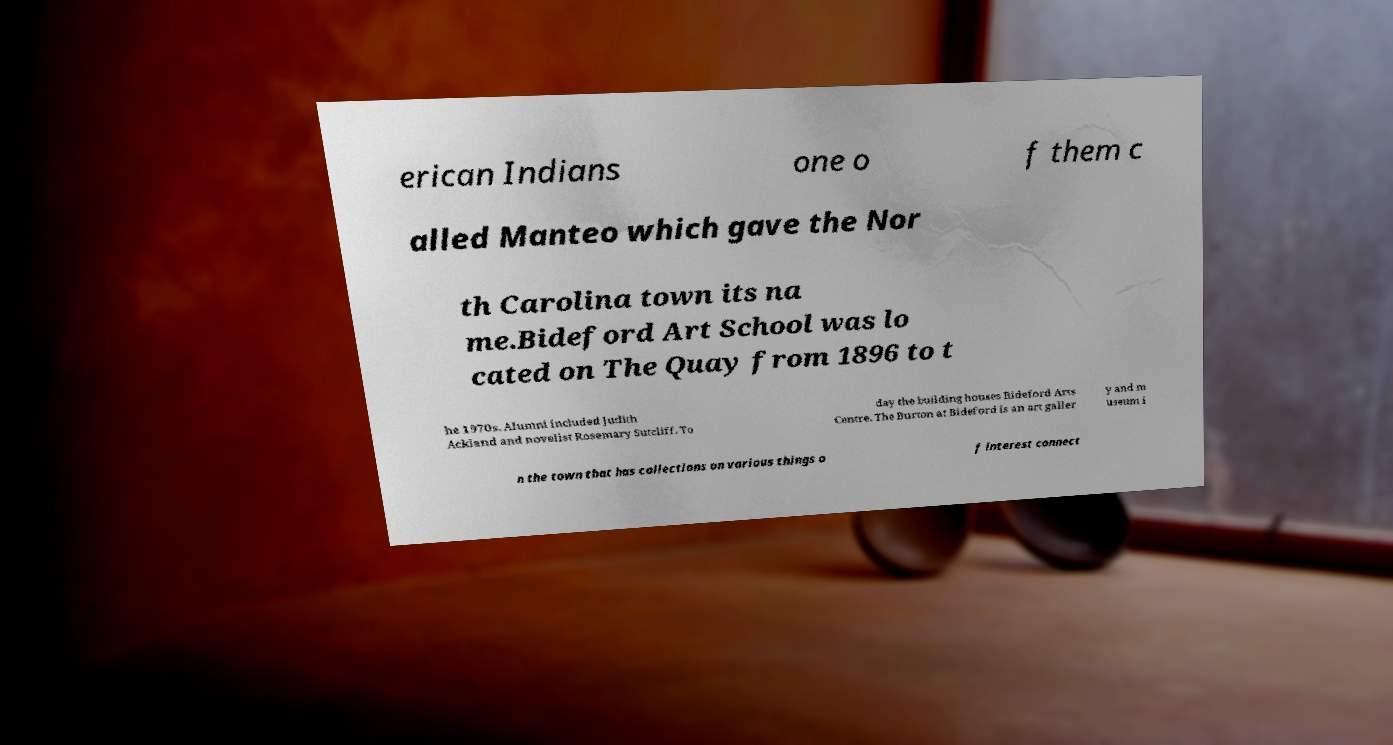Could you extract and type out the text from this image? erican Indians one o f them c alled Manteo which gave the Nor th Carolina town its na me.Bideford Art School was lo cated on The Quay from 1896 to t he 1970s. Alumni included Judith Ackland and novelist Rosemary Sutcliff. To day the building houses Bideford Arts Centre. The Burton at Bideford is an art galler y and m useum i n the town that has collections on various things o f interest connect 